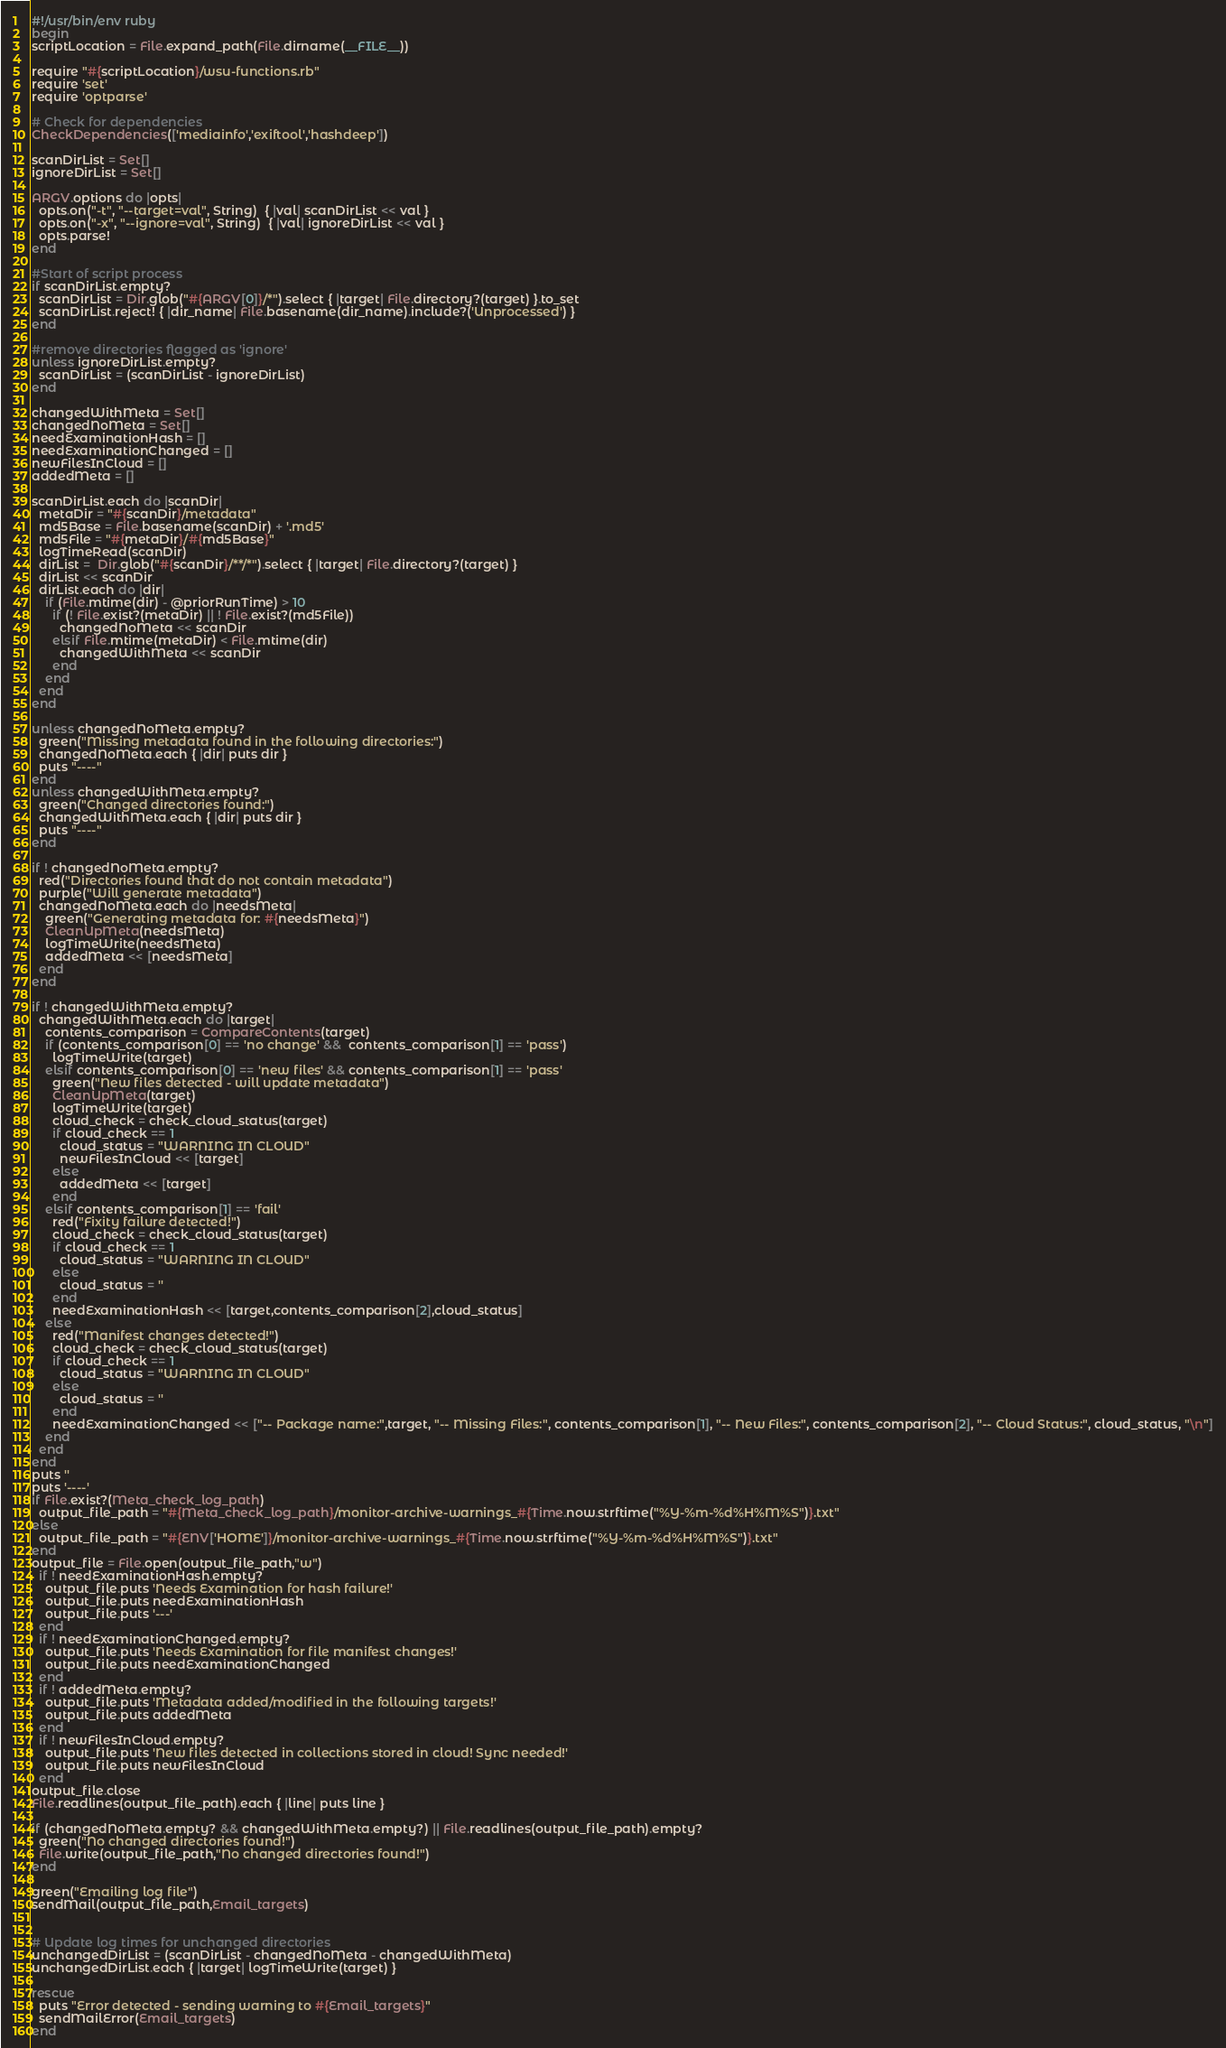<code> <loc_0><loc_0><loc_500><loc_500><_Ruby_>#!/usr/bin/env ruby
begin
scriptLocation = File.expand_path(File.dirname(__FILE__))

require "#{scriptLocation}/wsu-functions.rb"
require 'set'
require 'optparse'

# Check for dependencies
CheckDependencies(['mediainfo','exiftool','hashdeep'])

scanDirList = Set[]
ignoreDirList = Set[]

ARGV.options do |opts|
  opts.on("-t", "--target=val", String)  { |val| scanDirList << val }
  opts.on("-x", "--ignore=val", String)  { |val| ignoreDirList << val }
  opts.parse!
end

#Start of script process
if scanDirList.empty?
  scanDirList = Dir.glob("#{ARGV[0]}/*").select { |target| File.directory?(target) }.to_set
  scanDirList.reject! { |dir_name| File.basename(dir_name).include?('Unprocessed') }
end

#remove directories flagged as 'ignore'
unless ignoreDirList.empty?
  scanDirList = (scanDirList - ignoreDirList)
end

changedWithMeta = Set[]
changedNoMeta = Set[]
needExaminationHash = []
needExaminationChanged = []
newFilesInCloud = []
addedMeta = []

scanDirList.each do |scanDir|
  metaDir = "#{scanDir}/metadata"
  md5Base = File.basename(scanDir) + '.md5'
  md5File = "#{metaDir}/#{md5Base}"
  logTimeRead(scanDir)
  dirList =  Dir.glob("#{scanDir}/**/*").select { |target| File.directory?(target) }
  dirList << scanDir
  dirList.each do |dir|
    if (File.mtime(dir) - @priorRunTime) > 10
      if (! File.exist?(metaDir) || ! File.exist?(md5File))
        changedNoMeta << scanDir
      elsif File.mtime(metaDir) < File.mtime(dir)
        changedWithMeta << scanDir
      end
    end
  end
end

unless changedNoMeta.empty?
  green("Missing metadata found in the following directories:")
  changedNoMeta.each { |dir| puts dir }
  puts "----"
end
unless changedWithMeta.empty?
  green("Changed directories found:")
  changedWithMeta.each { |dir| puts dir }
  puts "----"
end

if ! changedNoMeta.empty?
  red("Directories found that do not contain metadata")
  purple("Will generate metadata")
  changedNoMeta.each do |needsMeta|
    green("Generating metadata for: #{needsMeta}")
    CleanUpMeta(needsMeta)
    logTimeWrite(needsMeta)
    addedMeta << [needsMeta]
  end
end

if ! changedWithMeta.empty?
  changedWithMeta.each do |target|
    contents_comparison = CompareContents(target)
    if (contents_comparison[0] == 'no change' &&  contents_comparison[1] == 'pass')
      logTimeWrite(target)
    elsif contents_comparison[0] == 'new files' && contents_comparison[1] == 'pass'
      green("New files detected - will update metadata")
      CleanUpMeta(target)
      logTimeWrite(target)
      cloud_check = check_cloud_status(target)
      if cloud_check == 1
        cloud_status = "WARNING IN CLOUD"
        newFilesInCloud << [target]
      else
        addedMeta << [target]
      end
    elsif contents_comparison[1] == 'fail'
      red("Fixity failure detected!")
      cloud_check = check_cloud_status(target)
      if cloud_check == 1
        cloud_status = "WARNING IN CLOUD"
      else
        cloud_status = ''
      end
      needExaminationHash << [target,contents_comparison[2],cloud_status]
    else
      red("Manifest changes detected!")
      cloud_check = check_cloud_status(target)
      if cloud_check == 1
        cloud_status = "WARNING IN CLOUD"
      else
        cloud_status = ''
      end
      needExaminationChanged << ["-- Package name:",target, "-- Missing Files:", contents_comparison[1], "-- New Files:", contents_comparison[2], "-- Cloud Status:", cloud_status, "\n"]
    end
  end
end
puts ''
puts '----'
if File.exist?(Meta_check_log_path)
  output_file_path = "#{Meta_check_log_path}/monitor-archive-warnings_#{Time.now.strftime("%Y-%m-%d%H%M%S")}.txt"
else
  output_file_path = "#{ENV['HOME']}/monitor-archive-warnings_#{Time.now.strftime("%Y-%m-%d%H%M%S")}.txt"
end
output_file = File.open(output_file_path,"w")
  if ! needExaminationHash.empty?
    output_file.puts 'Needs Examination for hash failure!'
    output_file.puts needExaminationHash
    output_file.puts '---'
  end
  if ! needExaminationChanged.empty?
    output_file.puts 'Needs Examination for file manifest changes!'
    output_file.puts needExaminationChanged
  end
  if ! addedMeta.empty?
    output_file.puts 'Metadata added/modified in the following targets!'
    output_file.puts addedMeta
  end
  if ! newFilesInCloud.empty?
    output_file.puts 'New files detected in collections stored in cloud! Sync needed!'
    output_file.puts newFilesInCloud
  end
output_file.close
File.readlines(output_file_path).each { |line| puts line }

if (changedNoMeta.empty? && changedWithMeta.empty?) || File.readlines(output_file_path).empty?
  green("No changed directories found!")
  File.write(output_file_path,"No changed directories found!")
end

green("Emailing log file")
sendMail(output_file_path,Email_targets)


# Update log times for unchanged directories
unchangedDirList = (scanDirList - changedNoMeta - changedWithMeta)
unchangedDirList.each { |target| logTimeWrite(target) }

rescue
  puts "Error detected - sending warning to #{Email_targets}"
  sendMailError(Email_targets)
end</code> 